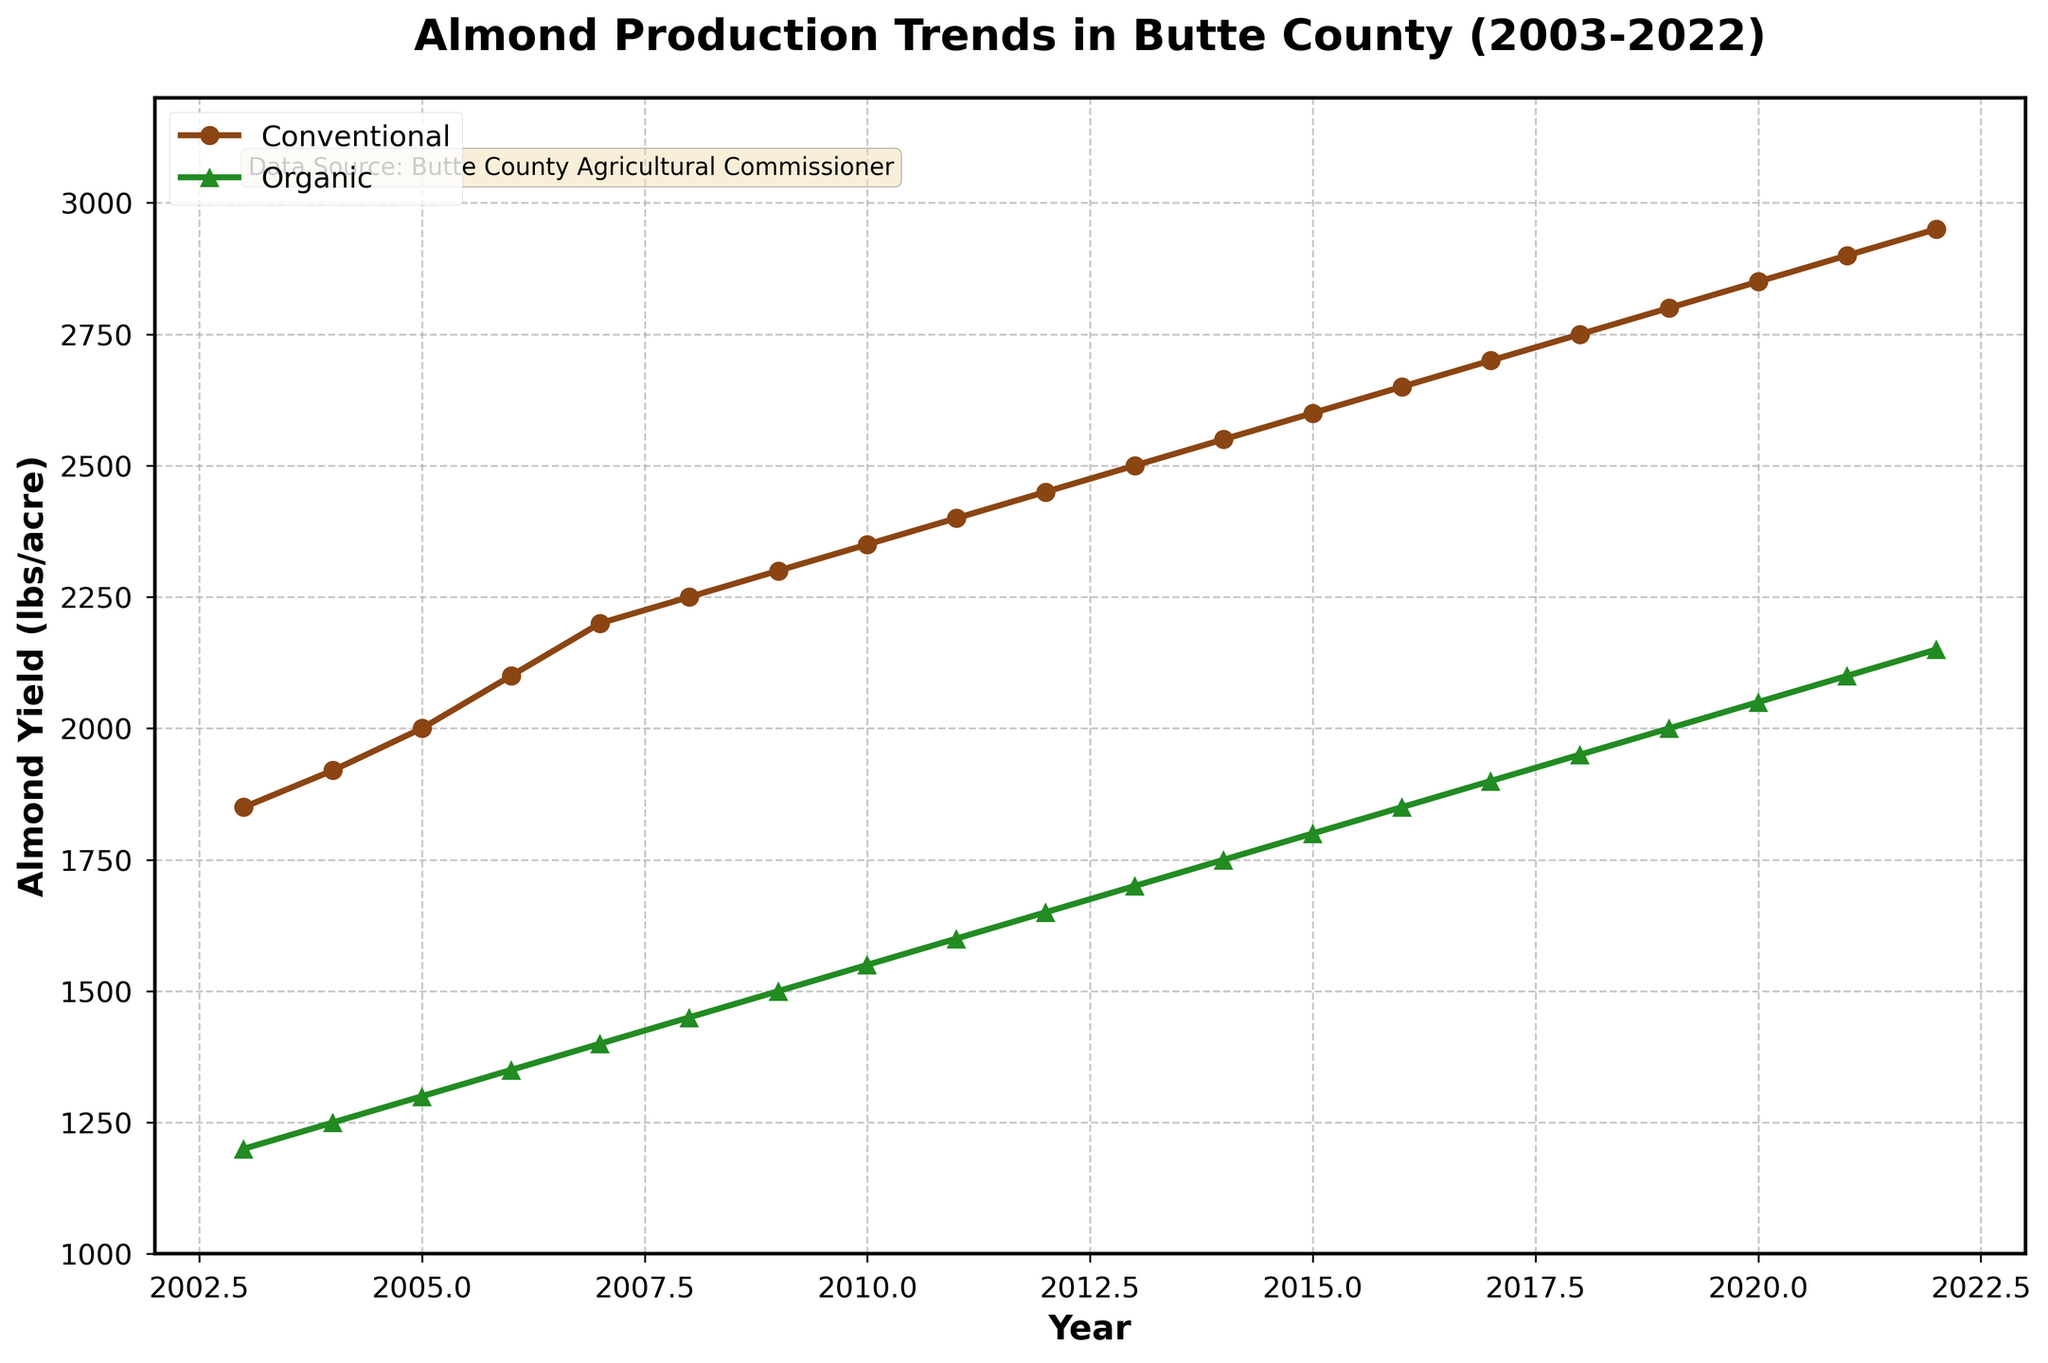What are the overall trends in almond yields for conventional and organic farming from 2003 to 2022? To analyze the trends, observe the slopes of the two lines. Both conventional and organic yields increase steadily over the years, implying a general upward trend in yield for both farming methods.
Answer: Upward trend for both How did the conventional almond yield change between 2008 and 2012? Look at the conventional yield for 2008 and 2012, which are 2250 lbs/acre and 2450 lbs/acre, respectively. The difference is 2450 - 2250 = 200 lbs/acre.
Answer: Increased by 200 lbs/acre In which year did organic almond yield first reach 2000 lbs/acre? Find where the green line (organic yield) first reaches 2000 on the y-axis. This occurs in the year 2019.
Answer: 2019 How much higher was the conventional yield compared to the organic yield in 2020? Look at the values for 2020—conventional yield is 2850 lbs/acre and organic yield is 2050 lbs/acre. The difference is 2850 - 2050 = 800 lbs/acre.
Answer: 800 lbs/acre What is the average annual increase in conventional almond yield from 2003 to 2022? The yield increased from 1850 lbs/acre in 2003 to 2950 lbs/acre in 2022. The total increase is 2950 - 1850 = 1100 lbs/acre over 19 years. So, the average annual increase is 1100 / 19 ≈ 57.89 lbs/acre per year.
Answer: ≈ 57.89 lbs/acre per year Which farming method showed a more consistent increase in almond yield over the years? Both lines are relatively smooth, but the organic yield line (green) has fewer fluctuations compared to the conventional yield line (brown).
Answer: Organic farming What is the total increase in organic almond yield from 2003 to 2022? Organic yield increased from 1200 lbs/acre in 2003 to 2150 lbs/acre in 2022. The total increase is 2150 - 1200 = 950 lbs/acre.
Answer: 950 lbs/acre How does the trend in organic yield compare with the trend in conventional yield after 2015? Both yield trends continue to increase, but the slopes of the lines indicate that both yields are increasing at similar rates.
Answer: Similar increases In which years were the differences between conventional and organic almond yields the least? This can be seen where the vertical distance between the brown and green lines is smallest, which is around 2003-2005. In these years, the yields were quite close.
Answer: 2003-2005 Which year showed the highest increase in organic yield from the previous year? Determine the annual differences for organic yield. The highest increase is between 2020 (2050 lbs/acre) and 2021 (2100 lbs/acre), which is an increase of 50 lbs/acre.
Answer: 2020-2021 